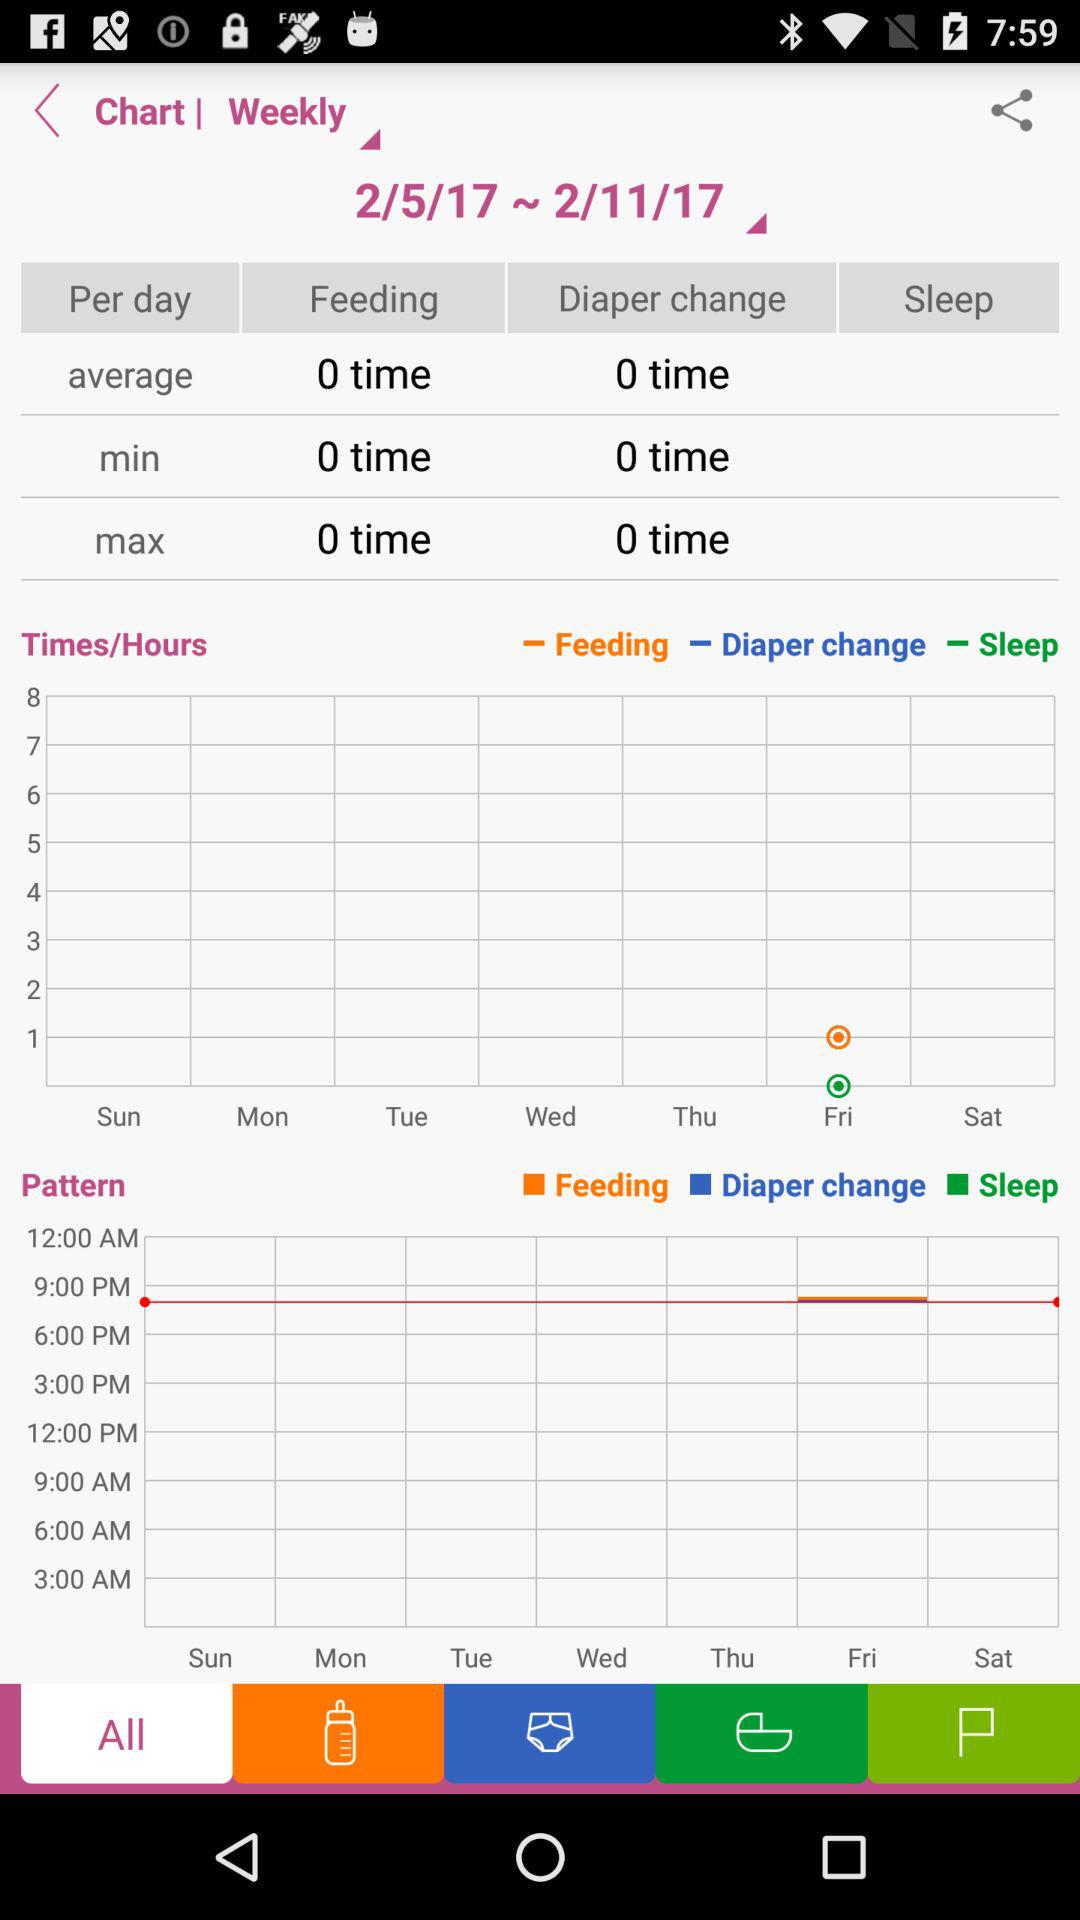How many times was the diaper changed on average? On average, the diaper was changed 0 times. 